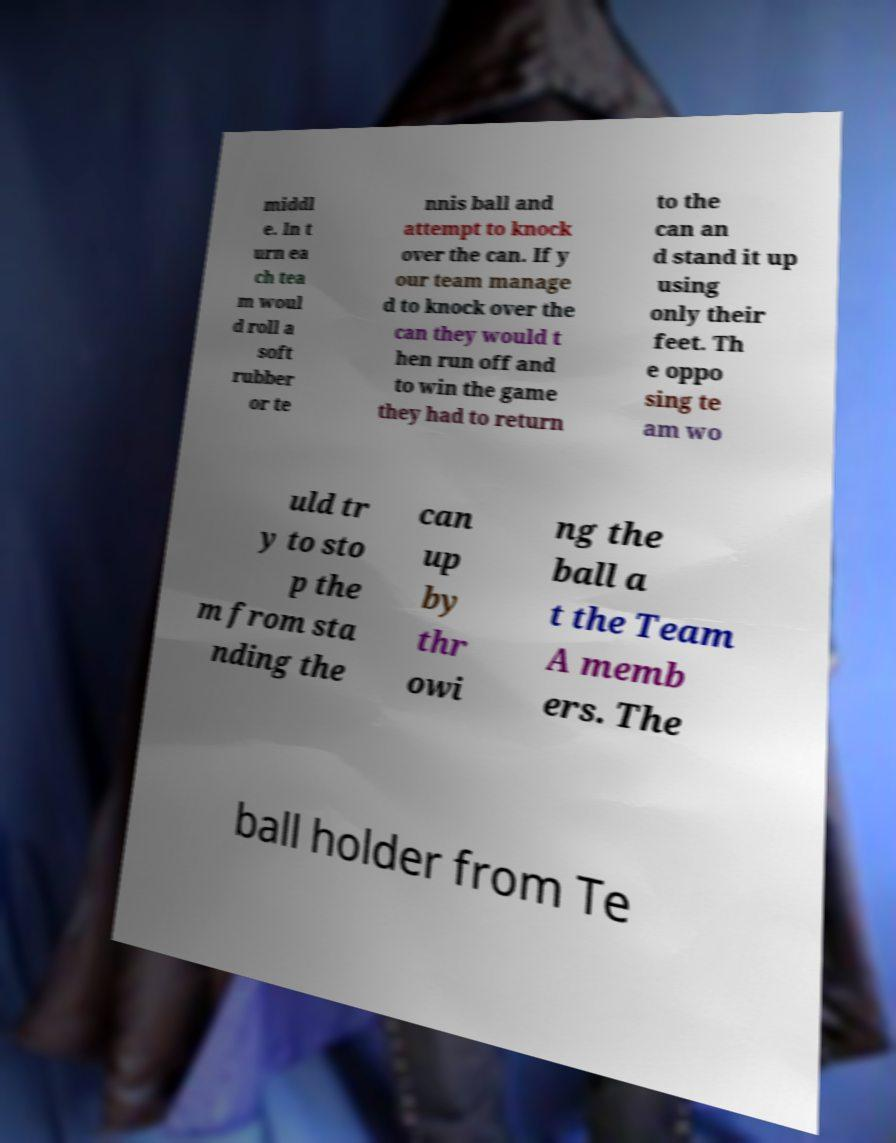Can you read and provide the text displayed in the image?This photo seems to have some interesting text. Can you extract and type it out for me? middl e. In t urn ea ch tea m woul d roll a soft rubber or te nnis ball and attempt to knock over the can. If y our team manage d to knock over the can they would t hen run off and to win the game they had to return to the can an d stand it up using only their feet. Th e oppo sing te am wo uld tr y to sto p the m from sta nding the can up by thr owi ng the ball a t the Team A memb ers. The ball holder from Te 